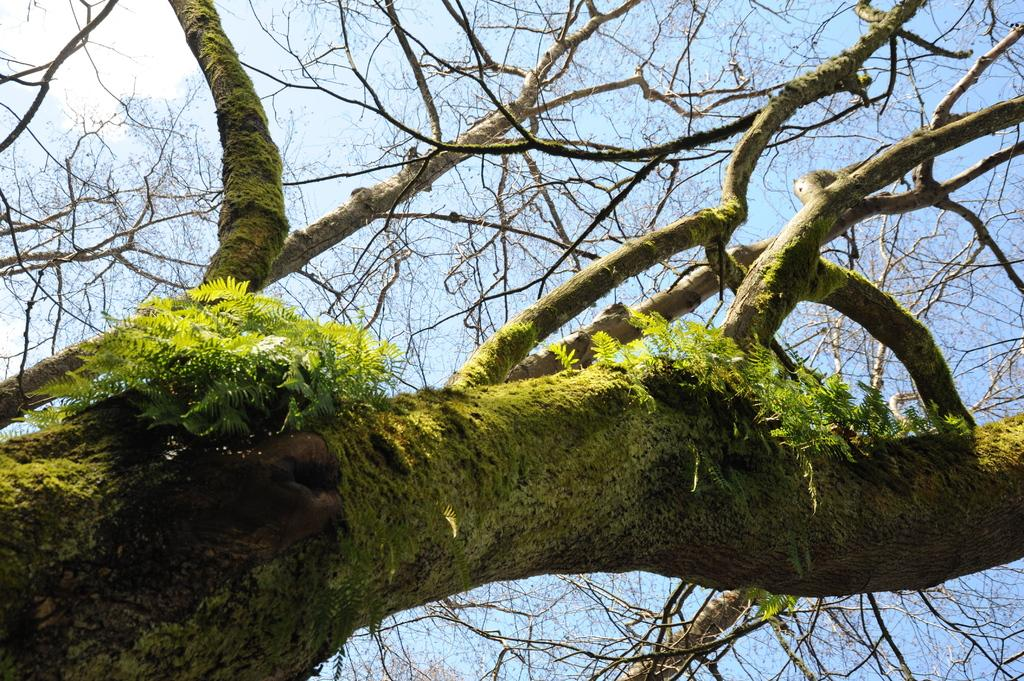What type of plant can be seen in the image? There is a tree in the image. What part of the tree is visible in the image? The tree has branches that are visible in the image. What can be seen in the background of the image? The sky is visible in the background of the image. How many toothbrushes are hanging from the tree in the image? There are no toothbrushes present in the image; it features a tree with branches. 